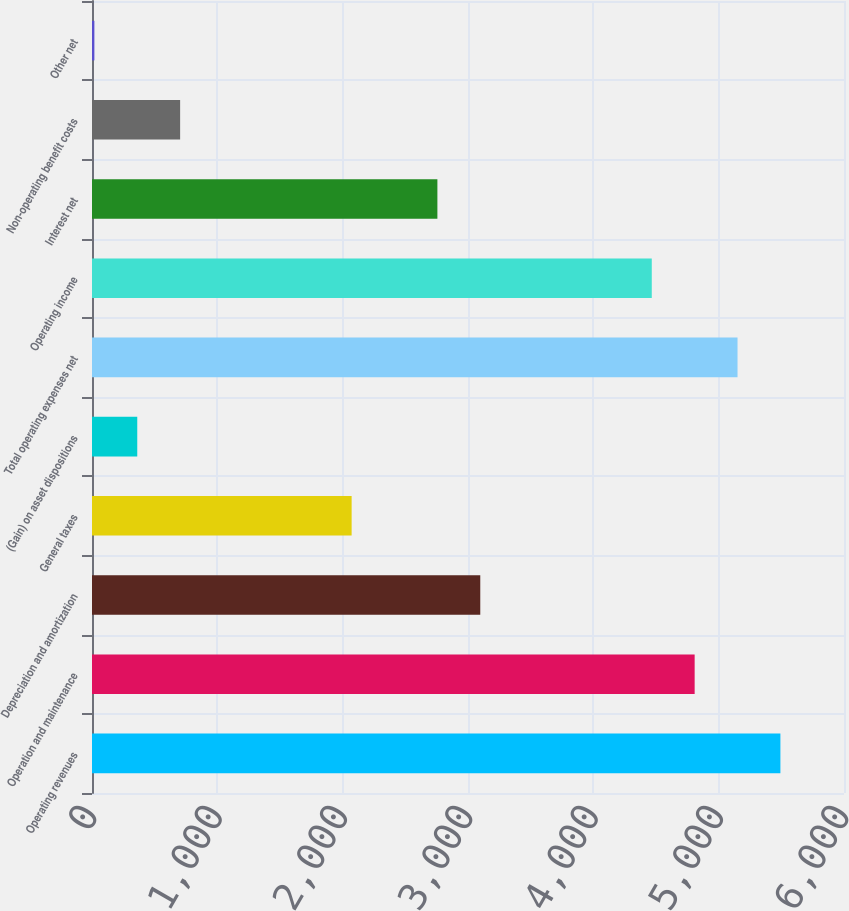Convert chart to OTSL. <chart><loc_0><loc_0><loc_500><loc_500><bar_chart><fcel>Operating revenues<fcel>Operation and maintenance<fcel>Depreciation and amortization<fcel>General taxes<fcel>(Gain) on asset dispositions<fcel>Total operating expenses net<fcel>Operating income<fcel>Interest net<fcel>Non-operating benefit costs<fcel>Other net<nl><fcel>5492.6<fcel>4808.4<fcel>3097.9<fcel>2071.6<fcel>361.1<fcel>5150.5<fcel>4466.3<fcel>2755.8<fcel>703.2<fcel>19<nl></chart> 